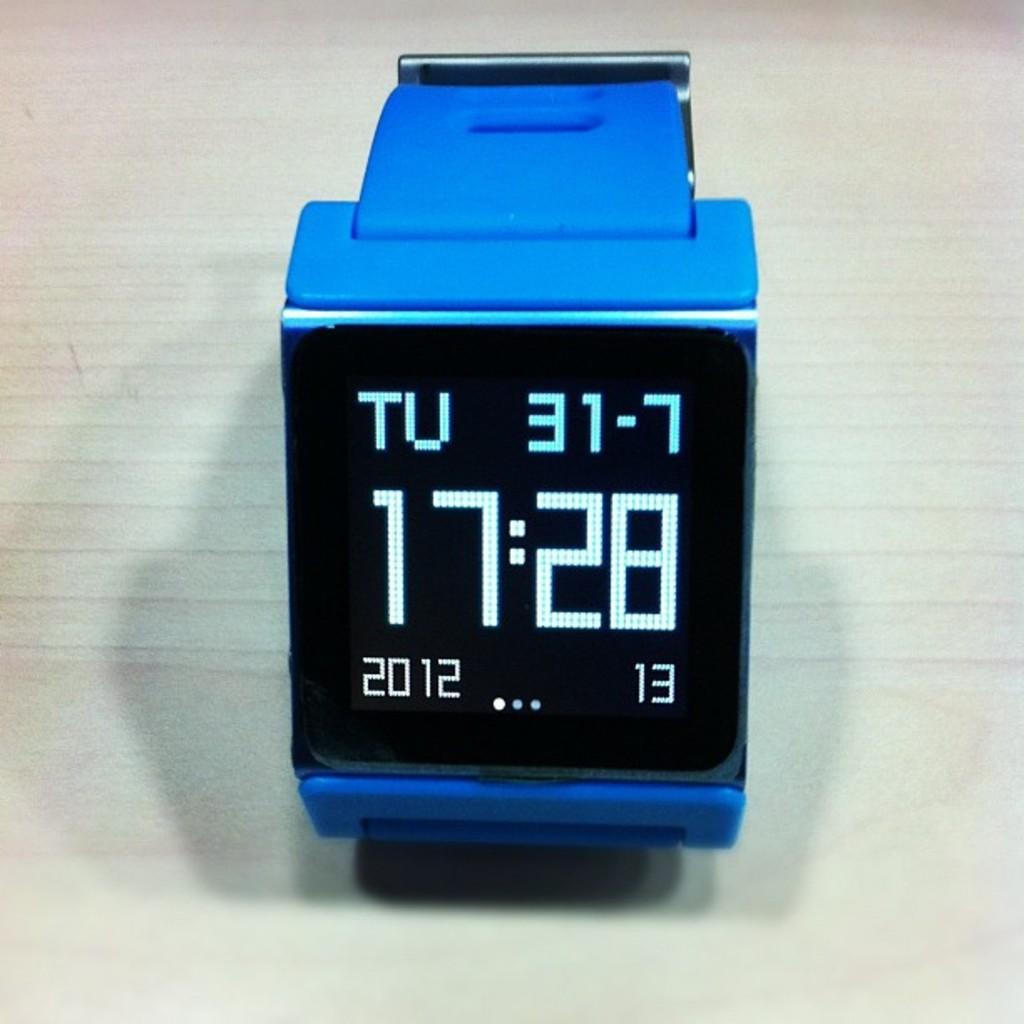What time does the watch say?
Your response must be concise. 17:28. What year is the date on the watch?
Offer a very short reply. 2012. 